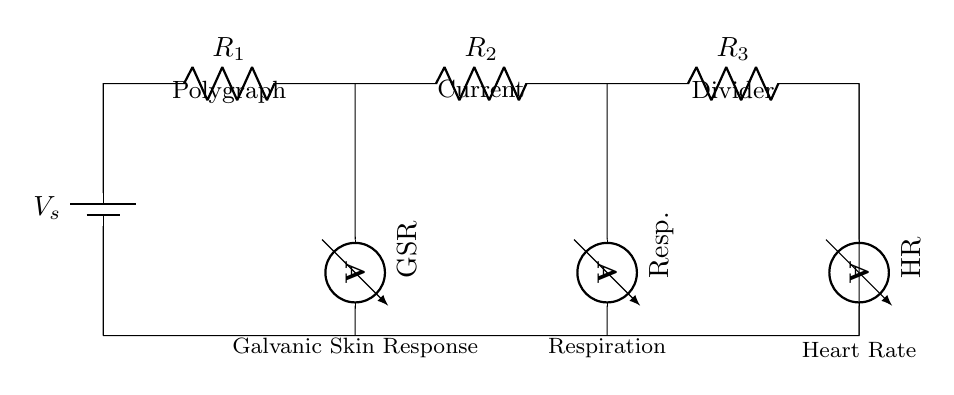what type of current measurement is shown for GSR? The GSR measures the Galvanic Skin Response using an ammeter, which indicates the flow of current associated with skin conductivity.
Answer: Galvanic Skin Response how many resistors are in the circuit? The circuit features three resistors connected in series, each represented distinctly.
Answer: Three which physiological response is measured at the HR? The HR measures heart rate, indicated in the circuit diagram as one of the ammeters associated with a resistor.
Answer: Heart Rate what happens to the current when the resistance increases? In a current divider, if the resistance of any branch increases, the current through that particular branch decreases, leading to an increase in current distribution in other branches depending on their resistance values.
Answer: Decreases what is the voltage source in this circuit? The voltage source is represented by the battery labeled as V_s, providing the necessary potential difference for the circuit to function and allow current flow.
Answer: V_s how is the current divided among the resistors? The current is divided according to the resistance values of each resistor. The higher the resistance, the smaller the current that flows through that path, illustrating the current divider rule where current inversely relates to resistance.
Answer: Inversely to resistance 